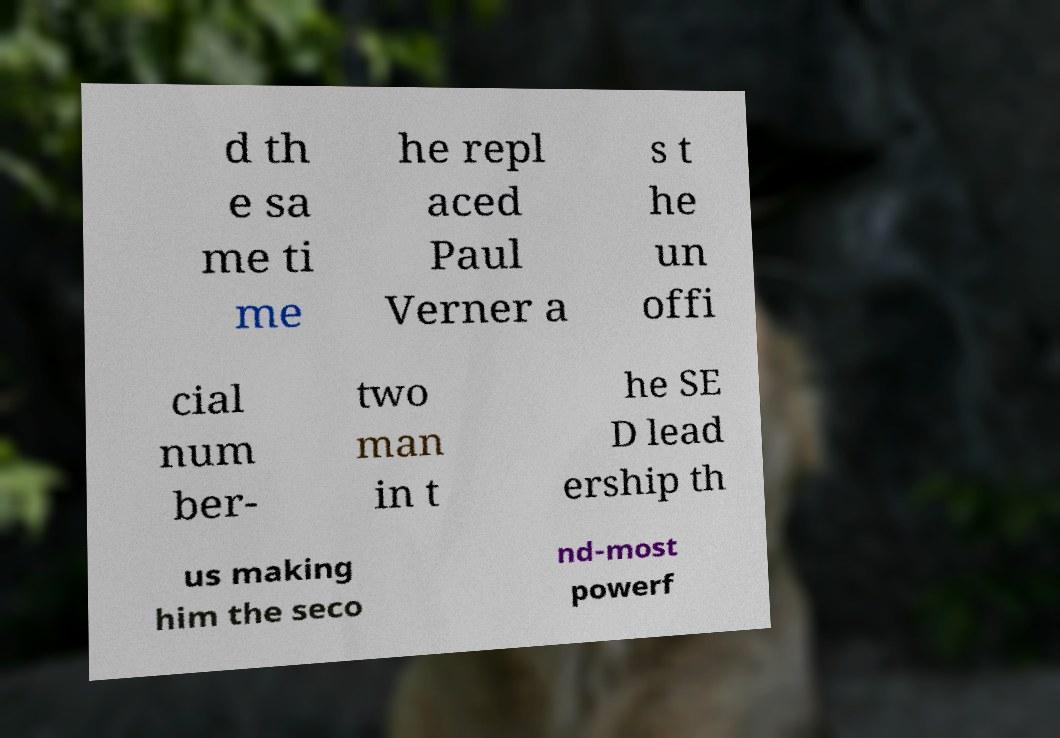Can you accurately transcribe the text from the provided image for me? d th e sa me ti me he repl aced Paul Verner a s t he un offi cial num ber- two man in t he SE D lead ership th us making him the seco nd-most powerf 